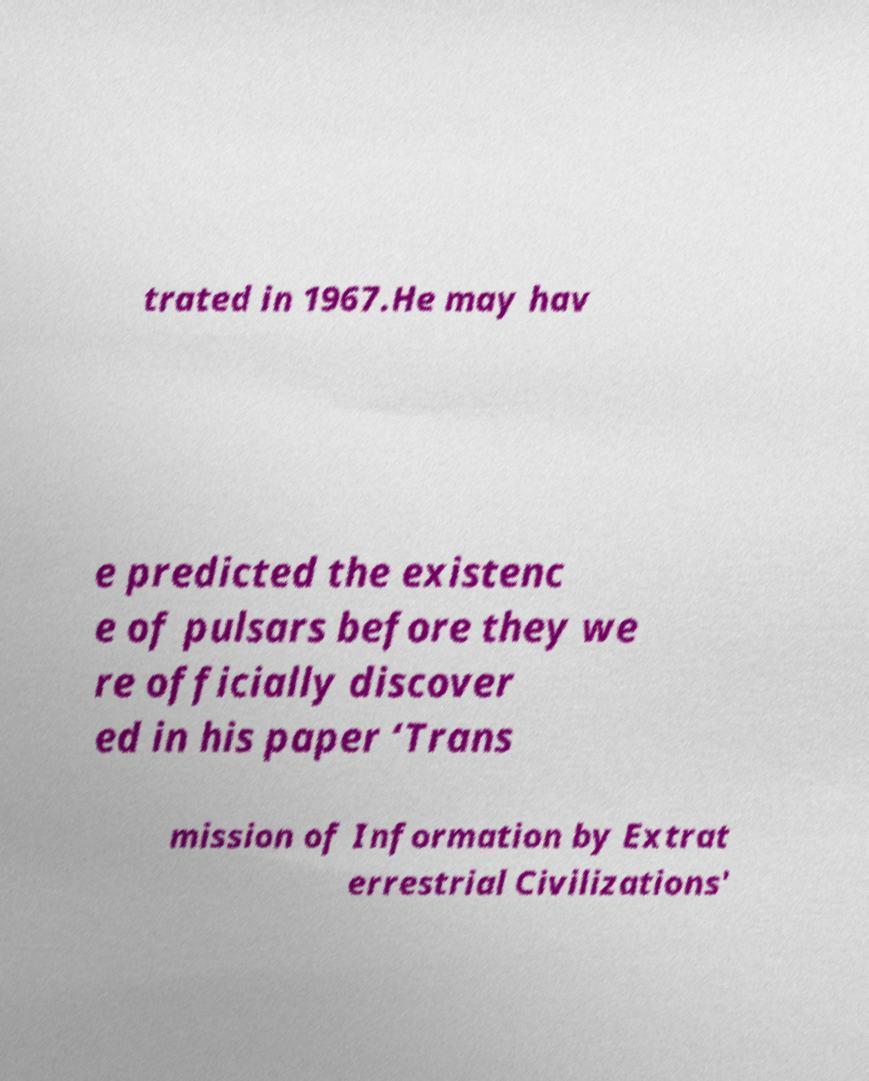I need the written content from this picture converted into text. Can you do that? trated in 1967.He may hav e predicted the existenc e of pulsars before they we re officially discover ed in his paper ‘Trans mission of Information by Extrat errestrial Civilizations' 